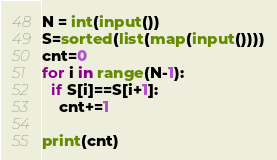Convert code to text. <code><loc_0><loc_0><loc_500><loc_500><_Python_>N = int(input())
S=sorted(list(map(input())))
cnt=0
for i in range(N-1):
  if S[i]==S[i+1]:
    cnt+=1
    
print(cnt)</code> 